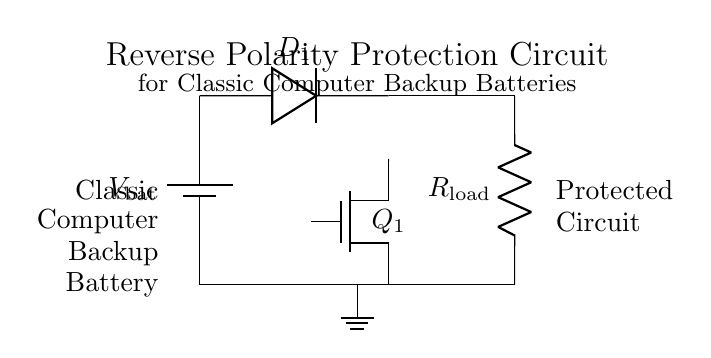What is the type of battery shown in the circuit? The circuit diagram indicates a battery symbol labeled as V_bat, which typically represents a DC power source. Hence, the type of battery is a direct current battery.
Answer: direct current battery What does the diode labeled D1 do in this circuit? In the circuit, the diode D1 allows current to flow in one direction only, providing reverse polarity protection by preventing reverse current that could damage the circuit.
Answer: prevent reverse current Which component is used as a switch in this circuit? The MOSFET component labeled Q1 acts as an electronic switch, allowing or blocking current flow under certain conditions, which is essential for reverse polarity protection.
Answer: MOSFET What is the purpose of the resistor R_load? The resistor R_load represents the load in the circuit, which consumes power from the battery while the system is operational and helps to simulate the actual load condition the circuit will encounter.
Answer: simulate the load condition In what state does the circuit operate when the battery is connected with correct polarity? When the battery is connected correctly, the diode D1 will conduct, allowing current to flow to the load R_load, enabling the circuit to function normally without issues.
Answer: functions normally What happens if the battery is connected with reverse polarity? In the case of reverse polarity, the diode D1 will block the current flow, preventing damage to the load and other components, thus protecting the circuit from potential faults.
Answer: blocks current flow 